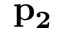<formula> <loc_0><loc_0><loc_500><loc_500>p _ { 2 }</formula> 